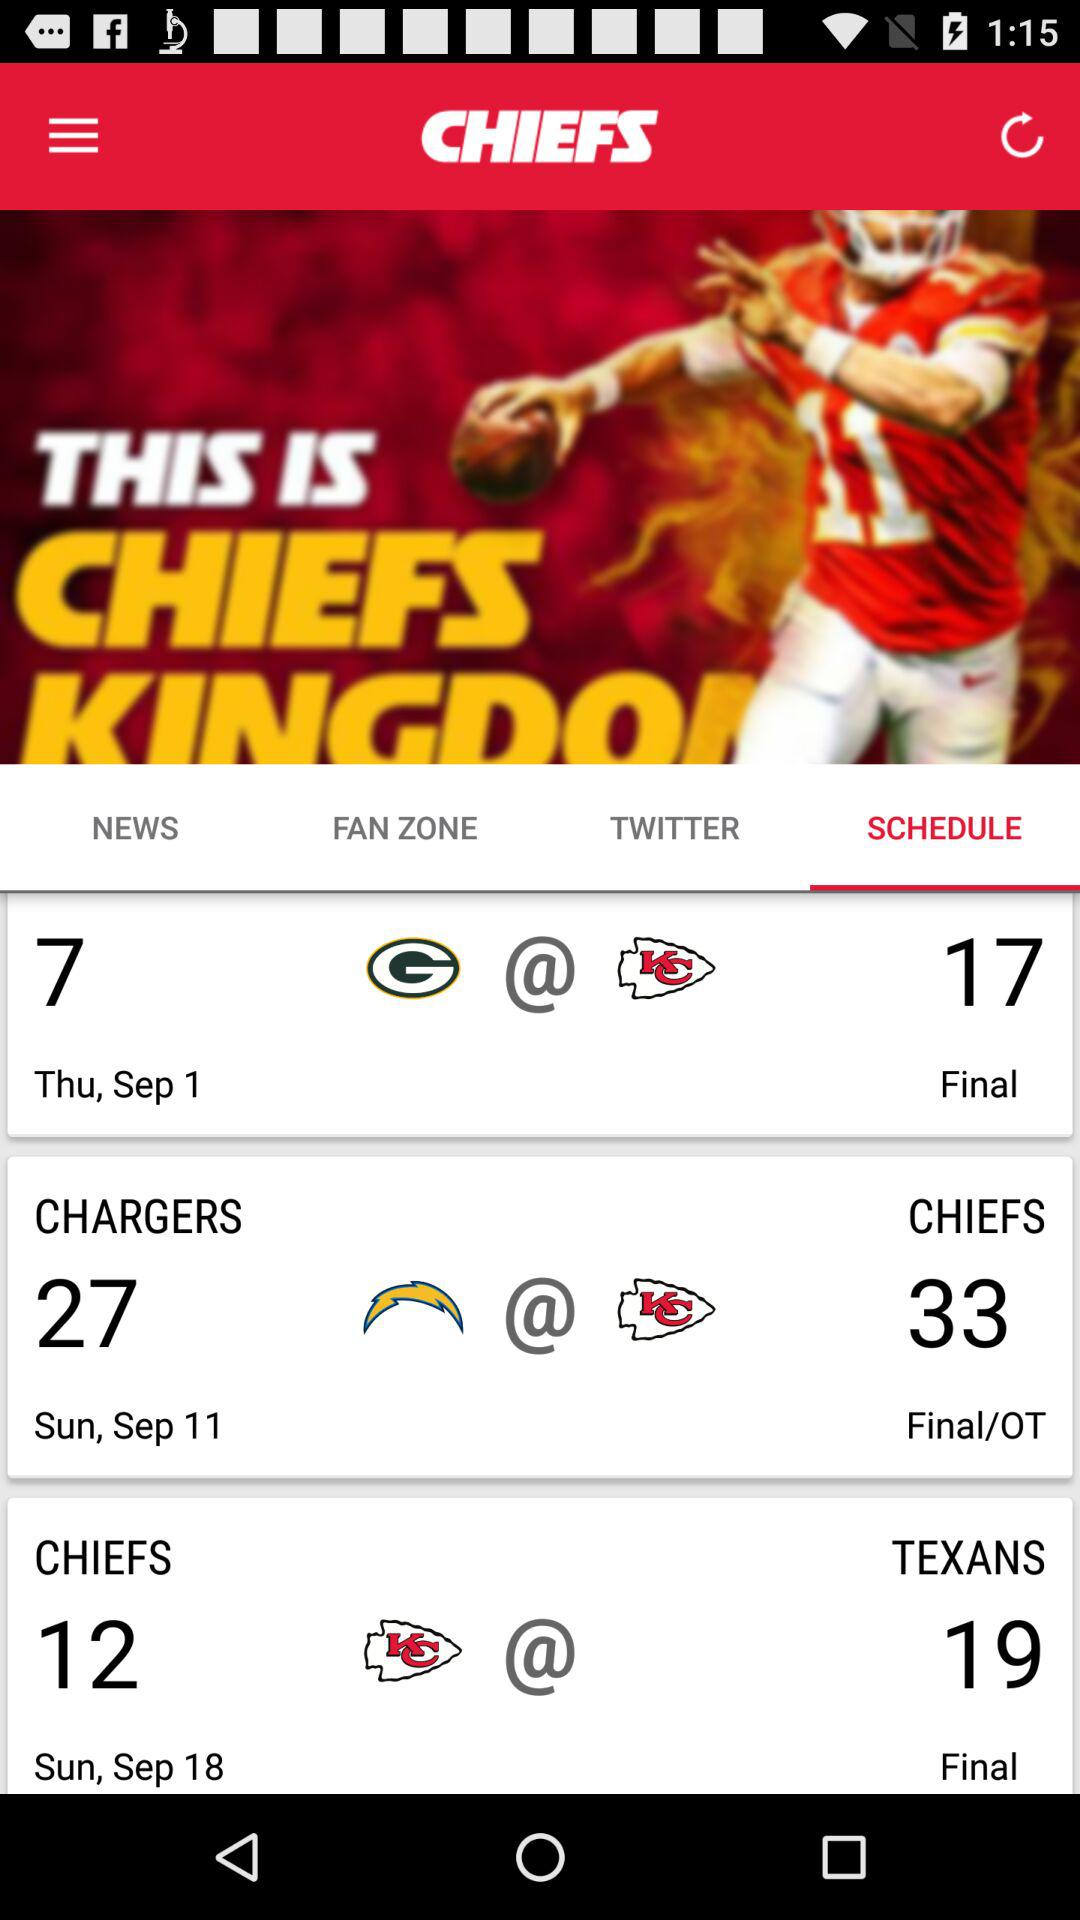How many games have a final score of 17?
Answer the question using a single word or phrase. 1 